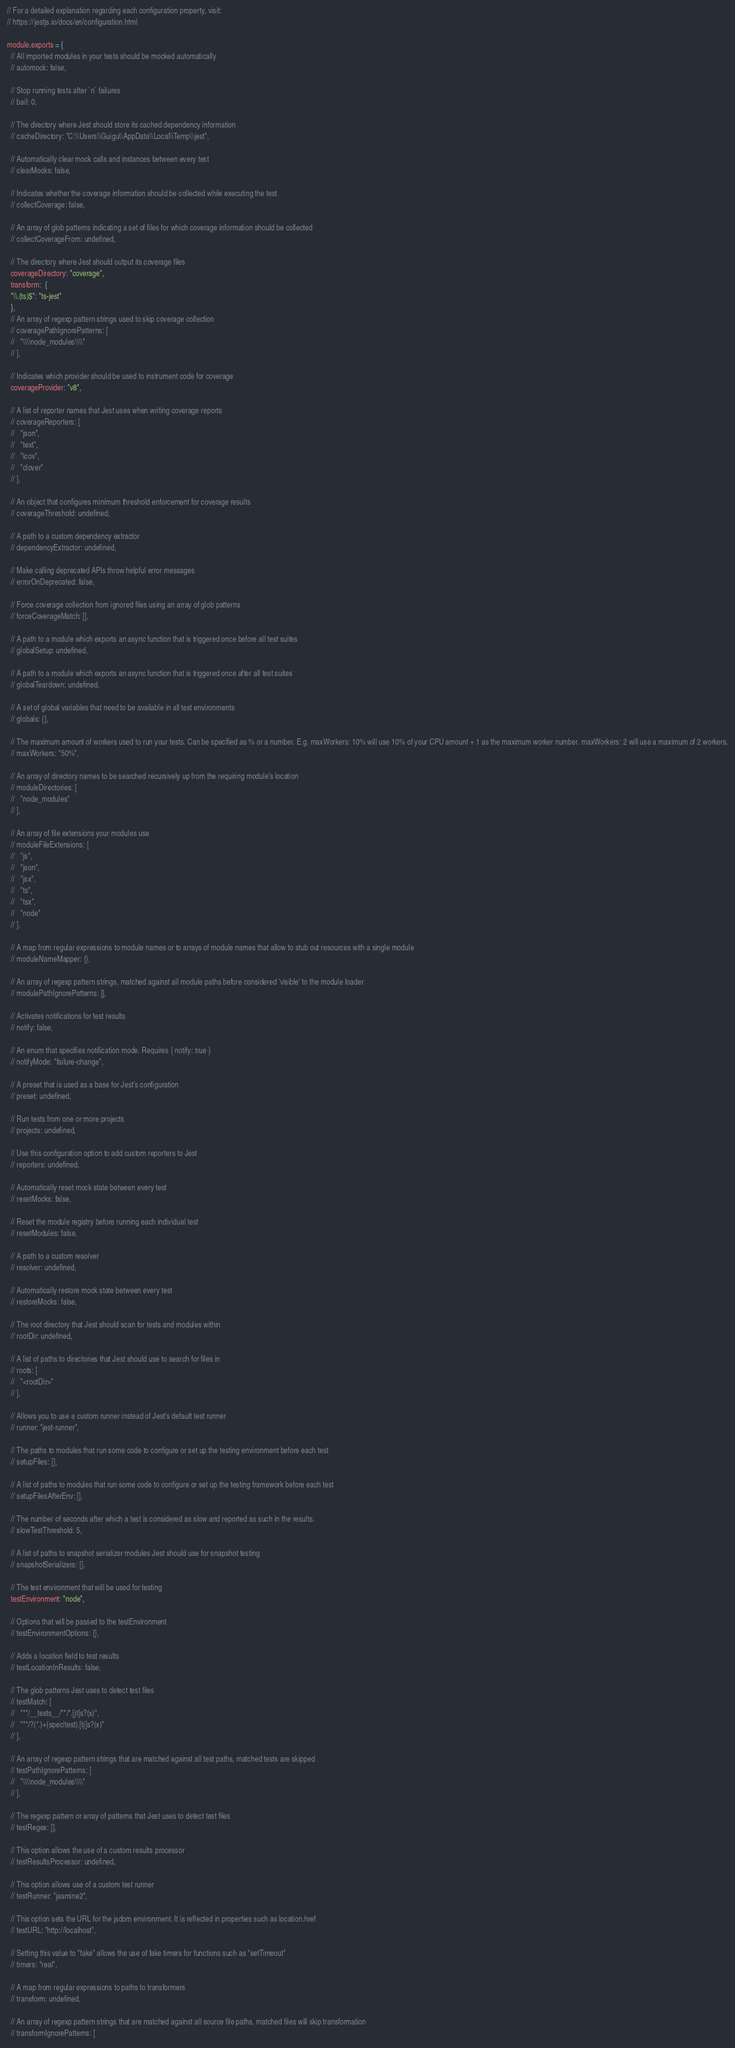<code> <loc_0><loc_0><loc_500><loc_500><_JavaScript_>// For a detailed explanation regarding each configuration property, visit:
// https://jestjs.io/docs/en/configuration.html

module.exports = {
  // All imported modules in your tests should be mocked automatically
  // automock: false,

  // Stop running tests after `n` failures
  // bail: 0,

  // The directory where Jest should store its cached dependency information
  // cacheDirectory: "C:\\Users\\Guigu\\AppData\\Local\\Temp\\jest",

  // Automatically clear mock calls and instances between every test
  // clearMocks: false,

  // Indicates whether the coverage information should be collected while executing the test
  // collectCoverage: false,

  // An array of glob patterns indicating a set of files for which coverage information should be collected
  // collectCoverageFrom: undefined,

  // The directory where Jest should output its coverage files
  coverageDirectory: "coverage",
  transform:  {
  "\\.(ts)$": "ts-jest"
  },
  // An array of regexp pattern strings used to skip coverage collection
  // coveragePathIgnorePatterns: [
  //   "\\\\node_modules\\\\"
  // ],

  // Indicates which provider should be used to instrument code for coverage
  coverageProvider: "v8",

  // A list of reporter names that Jest uses when writing coverage reports
  // coverageReporters: [
  //   "json",
  //   "text",
  //   "lcov",
  //   "clover"
  // ],

  // An object that configures minimum threshold enforcement for coverage results
  // coverageThreshold: undefined,

  // A path to a custom dependency extractor
  // dependencyExtractor: undefined,

  // Make calling deprecated APIs throw helpful error messages
  // errorOnDeprecated: false,

  // Force coverage collection from ignored files using an array of glob patterns
  // forceCoverageMatch: [],

  // A path to a module which exports an async function that is triggered once before all test suites
  // globalSetup: undefined,

  // A path to a module which exports an async function that is triggered once after all test suites
  // globalTeardown: undefined,

  // A set of global variables that need to be available in all test environments
  // globals: {},

  // The maximum amount of workers used to run your tests. Can be specified as % or a number. E.g. maxWorkers: 10% will use 10% of your CPU amount + 1 as the maximum worker number. maxWorkers: 2 will use a maximum of 2 workers.
  // maxWorkers: "50%",

  // An array of directory names to be searched recursively up from the requiring module's location
  // moduleDirectories: [
  //   "node_modules"
  // ],

  // An array of file extensions your modules use
  // moduleFileExtensions: [
  //   "js",
  //   "json",
  //   "jsx",
  //   "ts",
  //   "tsx",
  //   "node"
  // ],

  // A map from regular expressions to module names or to arrays of module names that allow to stub out resources with a single module
  // moduleNameMapper: {},

  // An array of regexp pattern strings, matched against all module paths before considered 'visible' to the module loader
  // modulePathIgnorePatterns: [],

  // Activates notifications for test results
  // notify: false,

  // An enum that specifies notification mode. Requires { notify: true }
  // notifyMode: "failure-change",

  // A preset that is used as a base for Jest's configuration
  // preset: undefined,

  // Run tests from one or more projects
  // projects: undefined,

  // Use this configuration option to add custom reporters to Jest
  // reporters: undefined,

  // Automatically reset mock state between every test
  // resetMocks: false,

  // Reset the module registry before running each individual test
  // resetModules: false,

  // A path to a custom resolver
  // resolver: undefined,

  // Automatically restore mock state between every test
  // restoreMocks: false,

  // The root directory that Jest should scan for tests and modules within
  // rootDir: undefined,

  // A list of paths to directories that Jest should use to search for files in
  // roots: [
  //   "<rootDir>"
  // ],

  // Allows you to use a custom runner instead of Jest's default test runner
  // runner: "jest-runner",

  // The paths to modules that run some code to configure or set up the testing environment before each test
  // setupFiles: [],

  // A list of paths to modules that run some code to configure or set up the testing framework before each test
  // setupFilesAfterEnv: [],

  // The number of seconds after which a test is considered as slow and reported as such in the results.
  // slowTestThreshold: 5,

  // A list of paths to snapshot serializer modules Jest should use for snapshot testing
  // snapshotSerializers: [],

  // The test environment that will be used for testing
  testEnvironment: "node",

  // Options that will be passed to the testEnvironment
  // testEnvironmentOptions: {},

  // Adds a location field to test results
  // testLocationInResults: false,

  // The glob patterns Jest uses to detect test files
  // testMatch: [
  //   "**/__tests__/**/*.[jt]s?(x)",
  //   "**/?(*.)+(spec|test).[tj]s?(x)"
  // ],

  // An array of regexp pattern strings that are matched against all test paths, matched tests are skipped
  // testPathIgnorePatterns: [
  //   "\\\\node_modules\\\\"
  // ],

  // The regexp pattern or array of patterns that Jest uses to detect test files
  // testRegex: [],

  // This option allows the use of a custom results processor
  // testResultsProcessor: undefined,

  // This option allows use of a custom test runner
  // testRunner: "jasmine2",

  // This option sets the URL for the jsdom environment. It is reflected in properties such as location.href
  // testURL: "http://localhost",

  // Setting this value to "fake" allows the use of fake timers for functions such as "setTimeout"
  // timers: "real",

  // A map from regular expressions to paths to transformers
  // transform: undefined,

  // An array of regexp pattern strings that are matched against all source file paths, matched files will skip transformation
  // transformIgnorePatterns: [</code> 